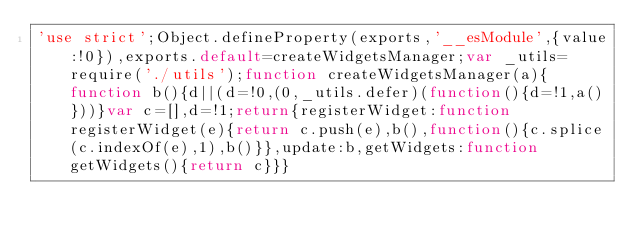Convert code to text. <code><loc_0><loc_0><loc_500><loc_500><_JavaScript_>'use strict';Object.defineProperty(exports,'__esModule',{value:!0}),exports.default=createWidgetsManager;var _utils=require('./utils');function createWidgetsManager(a){function b(){d||(d=!0,(0,_utils.defer)(function(){d=!1,a()}))}var c=[],d=!1;return{registerWidget:function registerWidget(e){return c.push(e),b(),function(){c.splice(c.indexOf(e),1),b()}},update:b,getWidgets:function getWidgets(){return c}}}</code> 